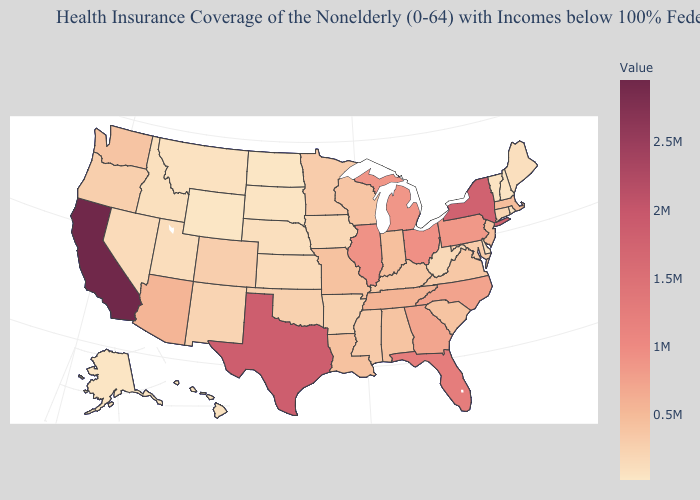Among the states that border Louisiana , does Arkansas have the lowest value?
Answer briefly. Yes. Does Kansas have a higher value than North Carolina?
Give a very brief answer. No. Among the states that border Pennsylvania , does West Virginia have the highest value?
Give a very brief answer. No. Does California have the lowest value in the West?
Quick response, please. No. Which states have the highest value in the USA?
Quick response, please. California. 